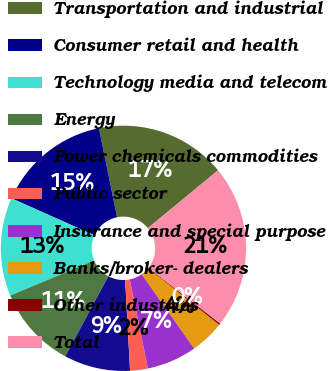Convert chart to OTSL. <chart><loc_0><loc_0><loc_500><loc_500><pie_chart><fcel>Transportation and industrial<fcel>Consumer retail and health<fcel>Technology media and telecom<fcel>Energy<fcel>Power chemicals commodities<fcel>Public sector<fcel>Insurance and special purpose<fcel>Banks/broker- dealers<fcel>Other industries<fcel>Total<nl><fcel>17.23%<fcel>15.11%<fcel>12.98%<fcel>10.85%<fcel>8.72%<fcel>2.34%<fcel>6.6%<fcel>4.47%<fcel>0.21%<fcel>21.49%<nl></chart> 